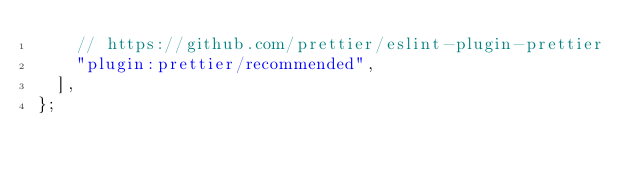Convert code to text. <code><loc_0><loc_0><loc_500><loc_500><_JavaScript_>    // https://github.com/prettier/eslint-plugin-prettier
    "plugin:prettier/recommended",
  ],
};
</code> 